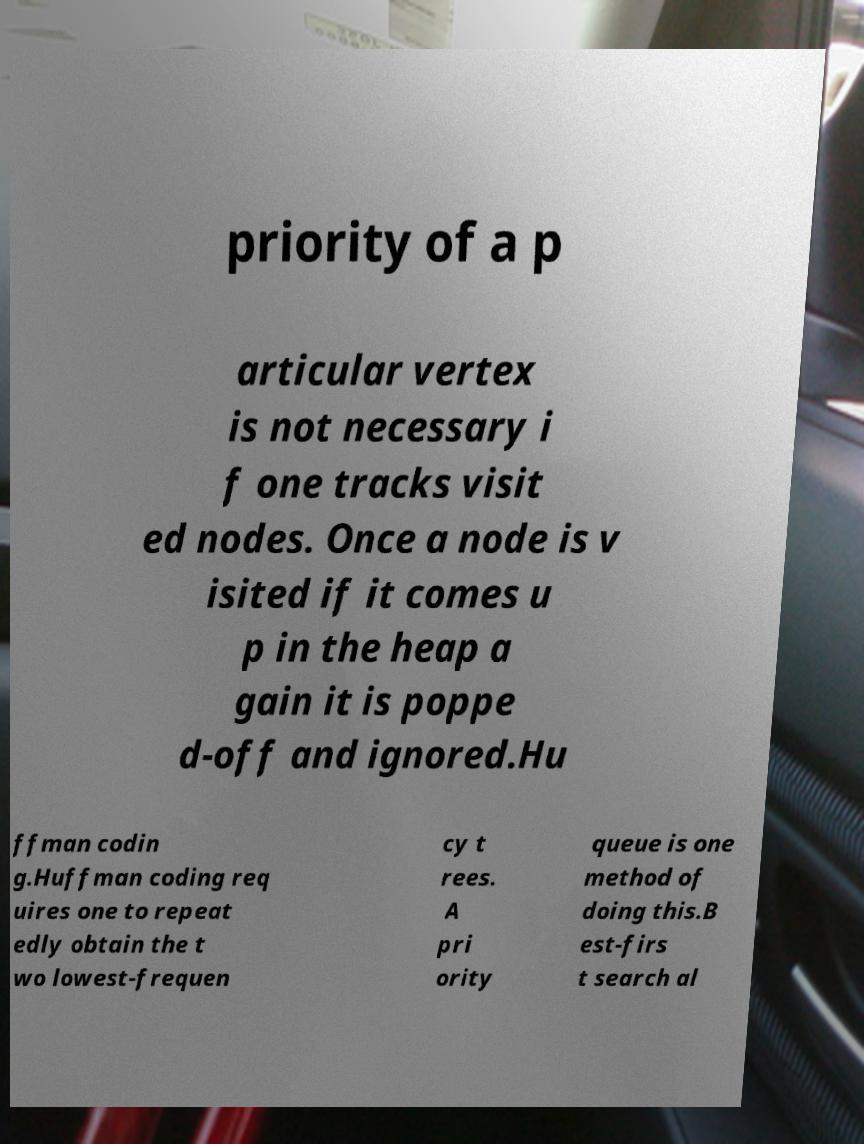Please identify and transcribe the text found in this image. priority of a p articular vertex is not necessary i f one tracks visit ed nodes. Once a node is v isited if it comes u p in the heap a gain it is poppe d-off and ignored.Hu ffman codin g.Huffman coding req uires one to repeat edly obtain the t wo lowest-frequen cy t rees. A pri ority queue is one method of doing this.B est-firs t search al 